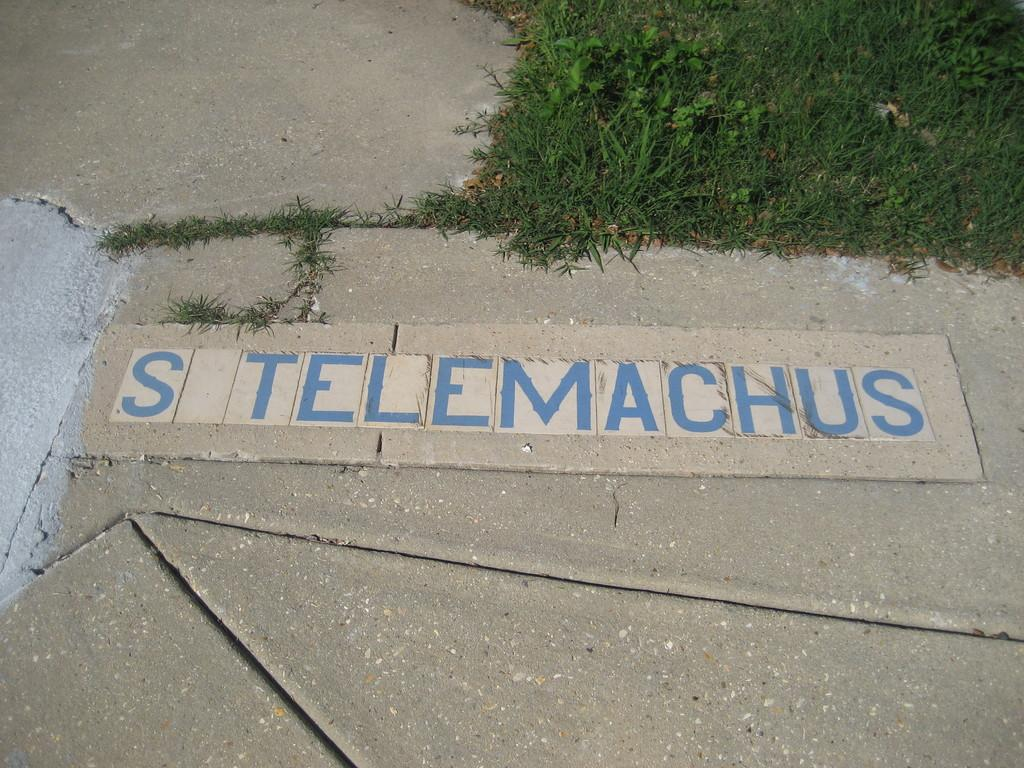What is written or depicted on the surface in the image? There are letters on a surface in the image. What type of natural environment can be seen in the image? There is grass visible in the image, which suggests a natural setting. What other living organisms are present in the image? There are plants in the image. How many cats can be seen stretching in the image? There are no cats present in the image, and therefore no stretching cats can be observed. 